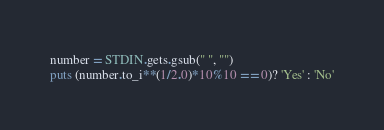<code> <loc_0><loc_0><loc_500><loc_500><_Ruby_>number = STDIN.gets.gsub(" ", "")
puts (number.to_i**(1/2.0)*10%10 == 0)? 'Yes' : 'No'
</code> 